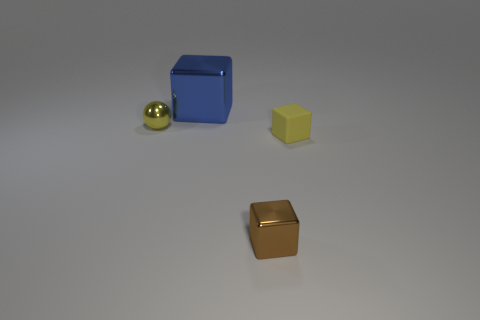Do the metal object that is on the left side of the big blue metallic thing and the tiny object in front of the tiny matte block have the same color?
Give a very brief answer. No. What is the color of the small thing that is both behind the small brown cube and right of the big blue shiny block?
Give a very brief answer. Yellow. Is the material of the yellow block the same as the tiny ball?
Your response must be concise. No. What number of small objects are either matte things or yellow shiny things?
Your response must be concise. 2. Is there anything else that has the same shape as the blue thing?
Provide a short and direct response. Yes. Are there any other things that have the same size as the metallic ball?
Your answer should be very brief. Yes. What is the color of the big object that is the same material as the small yellow sphere?
Keep it short and to the point. Blue. There is a shiny thing that is on the right side of the blue cube; what color is it?
Offer a very short reply. Brown. How many shiny cubes are the same color as the small rubber cube?
Keep it short and to the point. 0. Is the number of tiny blocks that are behind the matte object less than the number of brown blocks behind the blue metal block?
Provide a short and direct response. No. 